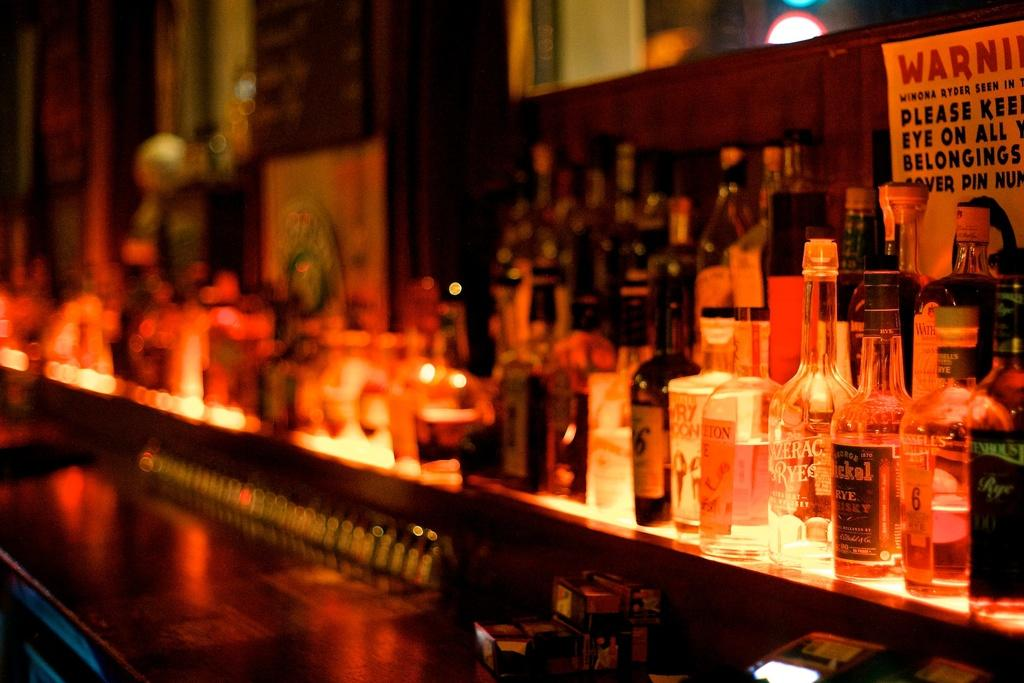What objects are present in the image? There are bottles in the image. Can you describe the bottles in the image? Unfortunately, the provided facts do not offer any additional details about the bottles. Are there any other objects or people visible in the image? The given facts do not mention any other objects or people in the image. What type of hobbies do the bears in the image enjoy? There are no bears present in the image, so it is not possible to determine their hobbies. 